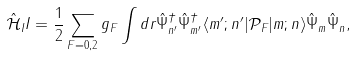Convert formula to latex. <formula><loc_0><loc_0><loc_500><loc_500>\hat { \mathcal { H } } _ { I } I = \frac { 1 } { 2 } \sum _ { F = 0 , 2 } g _ { F } \int d r \hat { \Psi } _ { n ^ { \prime } } ^ { \dag } \hat { \Psi } _ { m ^ { \prime } } ^ { \dag } \langle m ^ { \prime } ; n ^ { \prime } | \mathcal { P } _ { F } | m ; n \rangle \hat { \Psi } _ { m } \hat { \Psi } _ { n } ,</formula> 